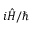Convert formula to latex. <formula><loc_0><loc_0><loc_500><loc_500>i { \hat { H } } / \hbar</formula> 